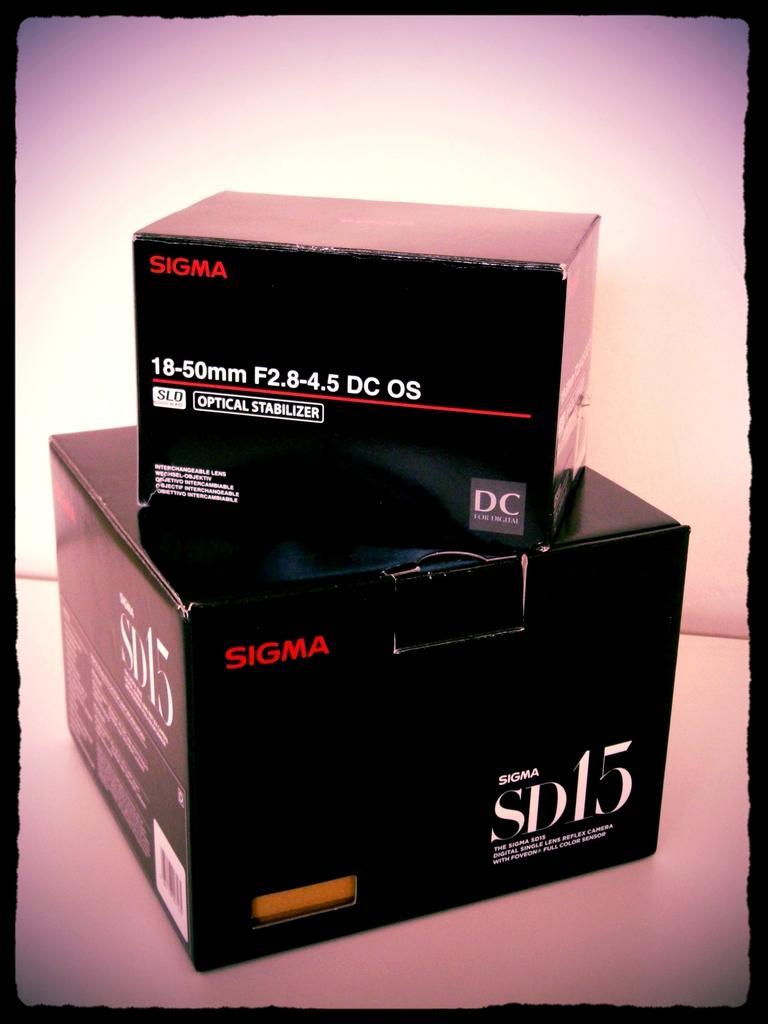Please provide a concise description of this image. This image is an edited image. In the middle of the image there are two cardboard boxes on the white surface. There is a text on the boxes. 